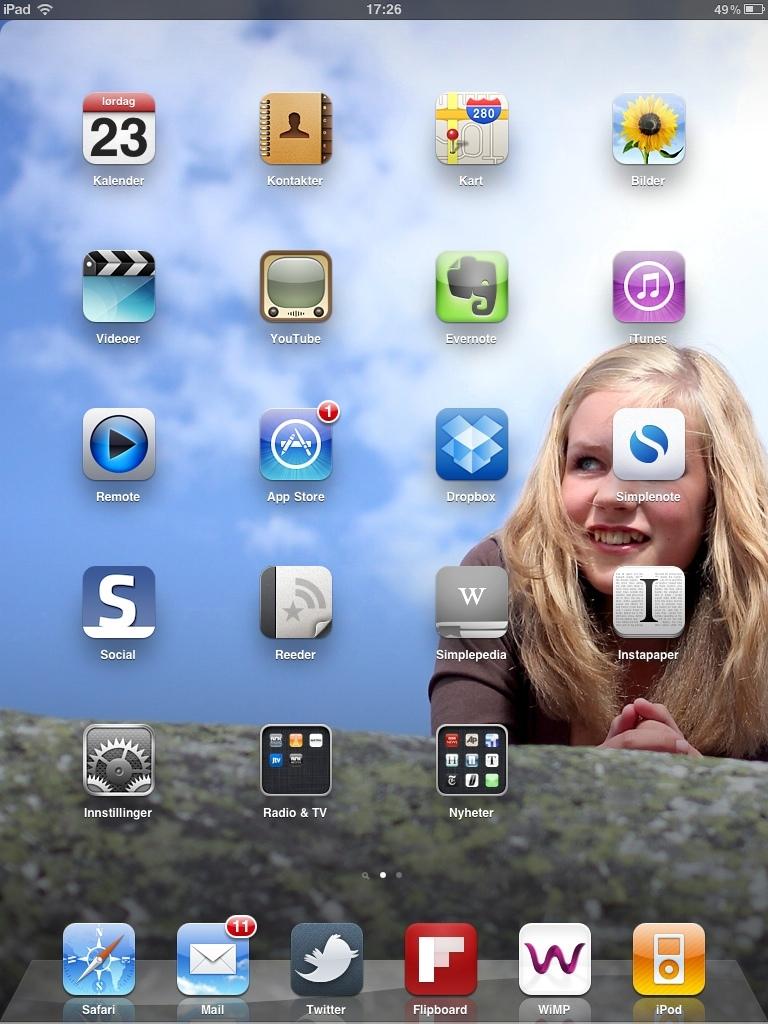How many messages does the mail app show having?
Offer a terse response. 11. What is the date on this computer?
Your answer should be compact. 23. 